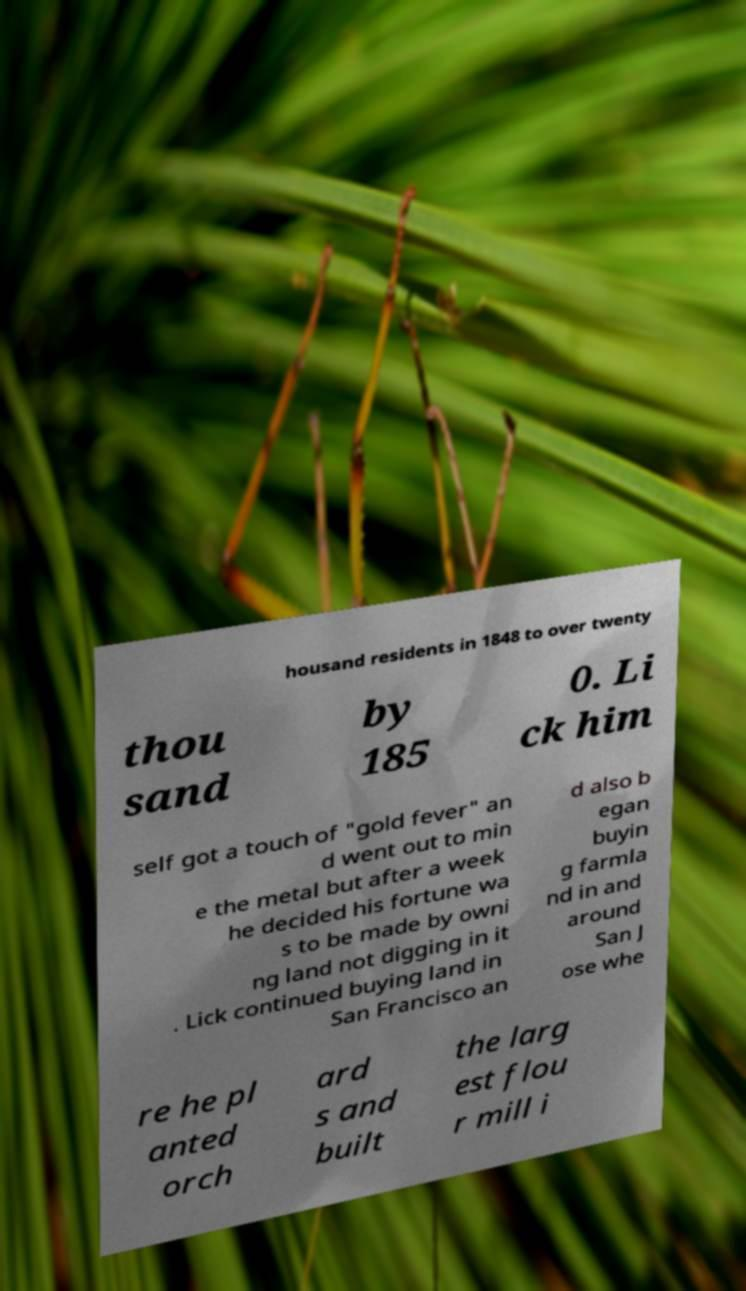I need the written content from this picture converted into text. Can you do that? housand residents in 1848 to over twenty thou sand by 185 0. Li ck him self got a touch of "gold fever" an d went out to min e the metal but after a week he decided his fortune wa s to be made by owni ng land not digging in it . Lick continued buying land in San Francisco an d also b egan buyin g farmla nd in and around San J ose whe re he pl anted orch ard s and built the larg est flou r mill i 